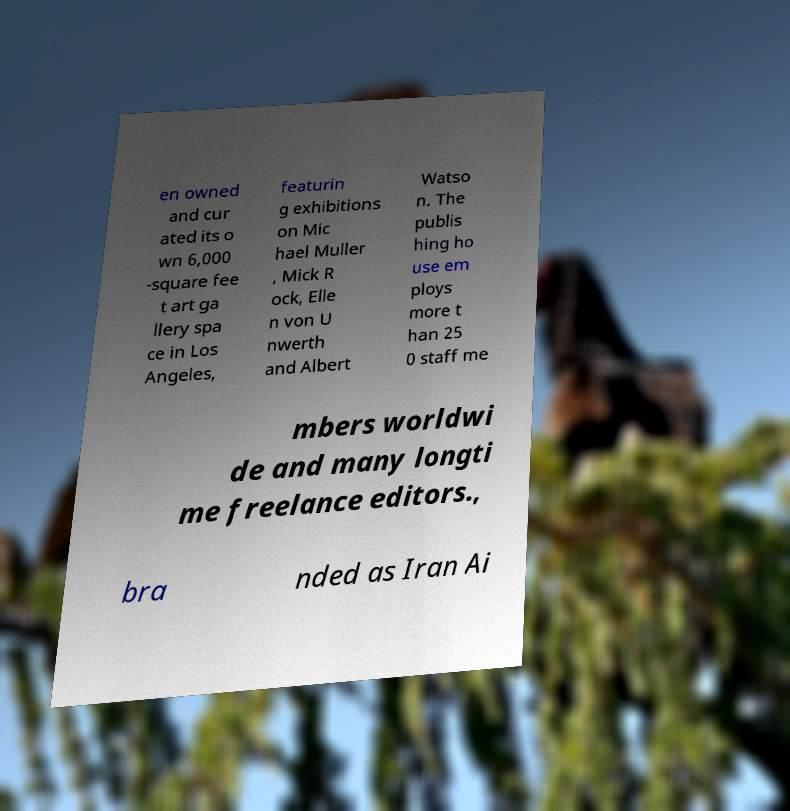For documentation purposes, I need the text within this image transcribed. Could you provide that? en owned and cur ated its o wn 6,000 -square fee t art ga llery spa ce in Los Angeles, featurin g exhibitions on Mic hael Muller , Mick R ock, Elle n von U nwerth and Albert Watso n. The publis hing ho use em ploys more t han 25 0 staff me mbers worldwi de and many longti me freelance editors., bra nded as Iran Ai 